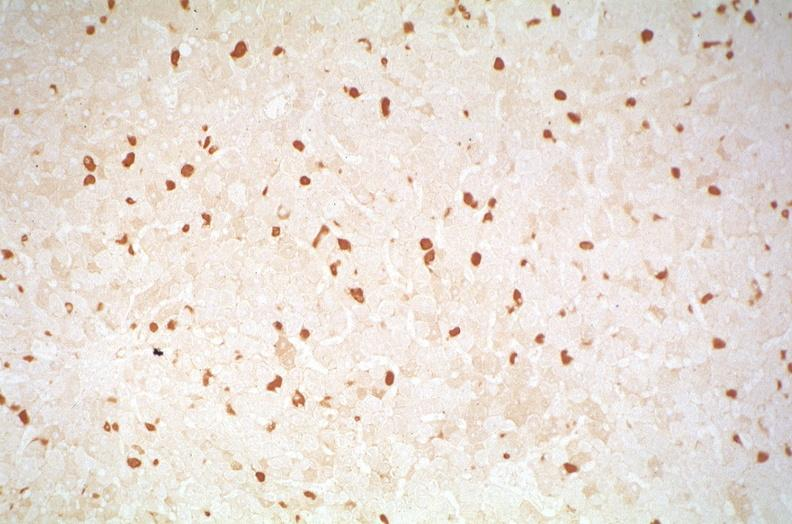s metastatic malignant melanoma present?
Answer the question using a single word or phrase. No 